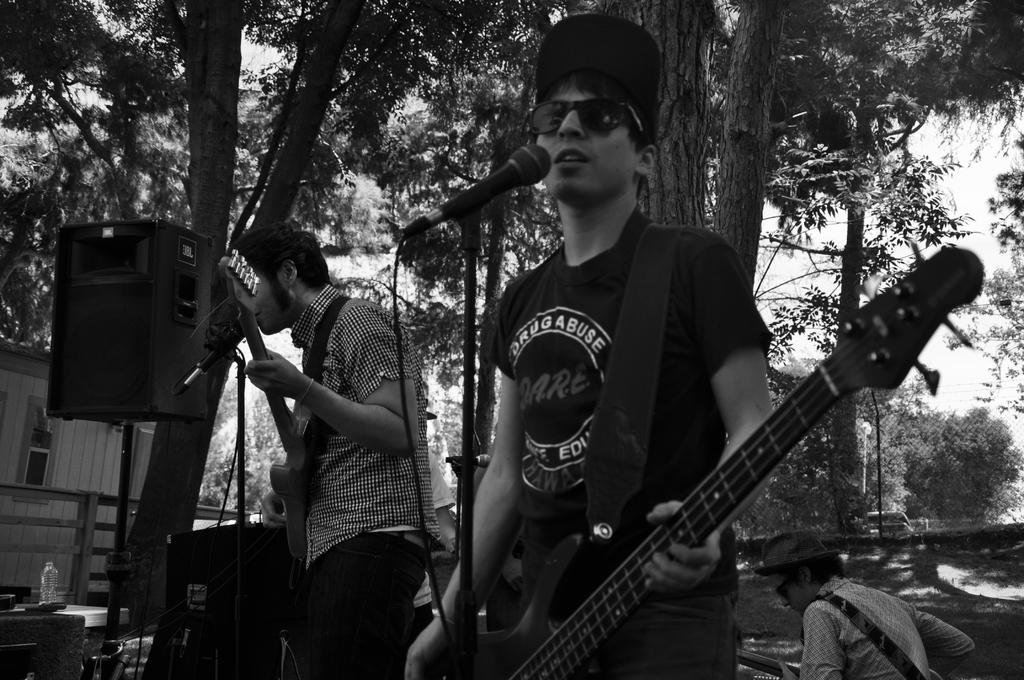How many people are in the image? There are two people in the image. What are the two people doing? The two people are playing guitars. What objects are in front of the people playing guitars? There are microphones in front of the people playing guitars. What type of vegetation can be seen in the image? There are trees visible in the image. What device is present for amplifying sound? There is a speaker in the image. Can you describe the person behind the two people playing guitars? There is a person behind the two people playing guitars, but their actions or appearance are not specified in the provided facts. What type of growth can be seen on the guitars in the image? There is no growth visible on the guitars in the image. What type of light is being offered by the person behind the two people playing guitars? There is no mention of light or an offering in the image. 